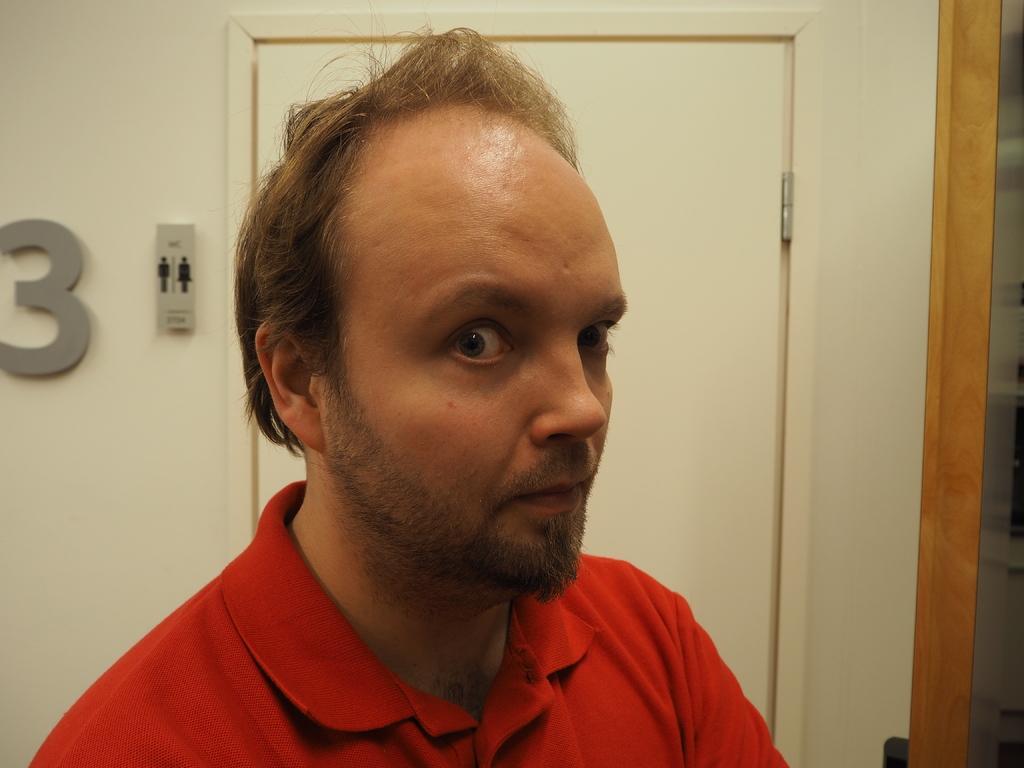Please provide a concise description of this image. In the image we can see there is a person standing and he is wearing red colour t shirt. Behind there is a white colour wall. 